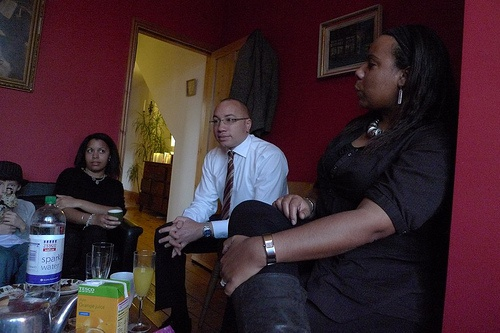Describe the objects in this image and their specific colors. I can see people in black, gray, and maroon tones, people in black, darkgray, and gray tones, people in black, gray, and maroon tones, people in black, gray, and navy tones, and bottle in black, lightblue, and gray tones in this image. 